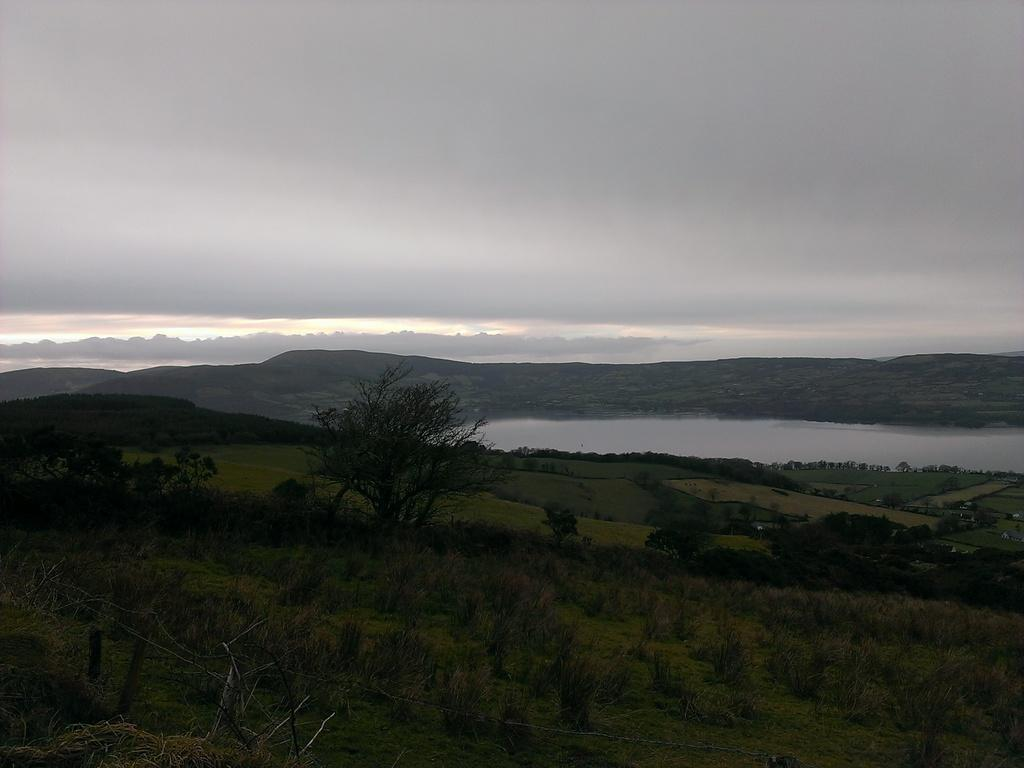What type of natural elements can be seen in the image? There are trees, water, and mountains visible in the image. What is the color of the sky in the image? The sky is a combination of white and grey colors in the image. What type of verse can be heard recited by the zephyr in the image? There is no zephyr or verse present in the image; it features natural elements such as trees, water, mountains, and a sky with white and grey colors. 